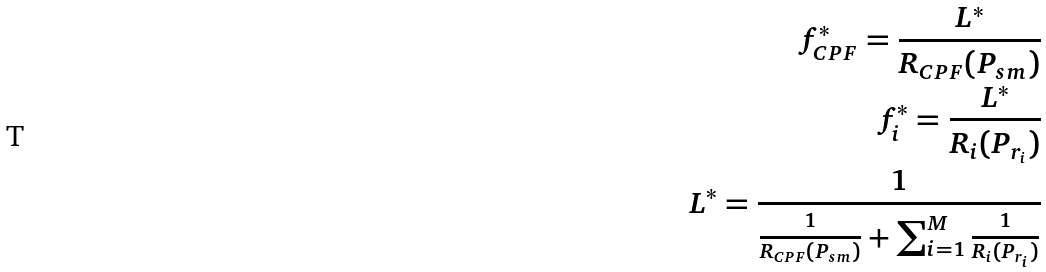<formula> <loc_0><loc_0><loc_500><loc_500>f _ { C P F } ^ { * } = \frac { L ^ { * } } { R _ { C P F } ( P _ { s m } ) } \\ f _ { i } ^ { * } = \frac { L ^ { * } } { R _ { i } ( P _ { r _ { i } } ) } \\ L ^ { * } = \frac { 1 } { \frac { 1 } { R _ { C P F } ( P _ { s m } ) } + \sum _ { i = 1 } ^ { M } \frac { 1 } { R _ { i } ( P _ { r _ { i } } ) } }</formula> 